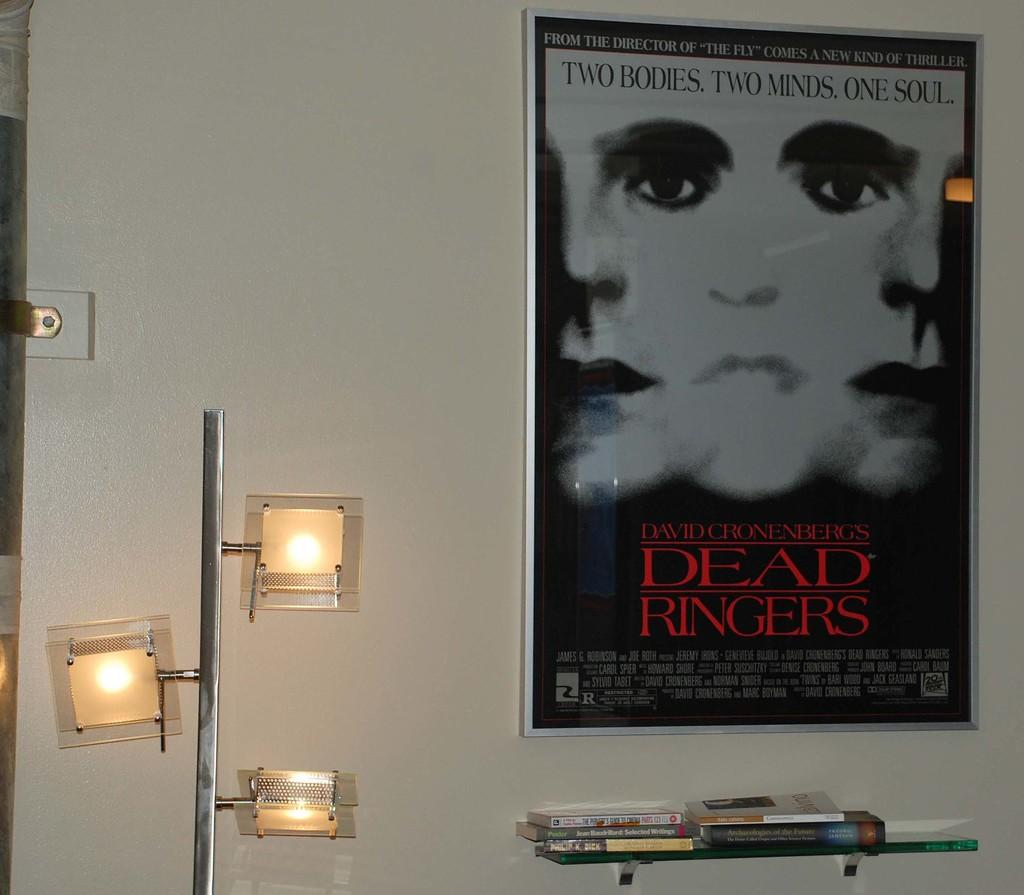<image>
Give a short and clear explanation of the subsequent image. a poster for dead ringers on the wall 